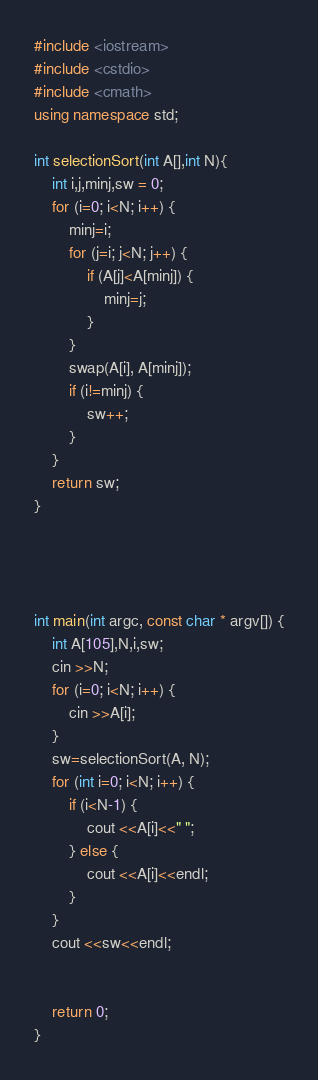<code> <loc_0><loc_0><loc_500><loc_500><_C++_>#include <iostream>
#include <cstdio>
#include <cmath>
using namespace std;

int selectionSort(int A[],int N){
    int i,j,minj,sw = 0;
    for (i=0; i<N; i++) {
        minj=i;
        for (j=i; j<N; j++) {
            if (A[j]<A[minj]) {
                minj=j;
            }
        }
        swap(A[i], A[minj]);
        if (i!=minj) {
            sw++;
        }
    }
    return sw;
}




int main(int argc, const char * argv[]) {
    int A[105],N,i,sw;
    cin >>N;
    for (i=0; i<N; i++) {
        cin >>A[i];
    }
    sw=selectionSort(A, N);
    for (int i=0; i<N; i++) {
        if (i<N-1) {
            cout <<A[i]<<" ";
        } else {
            cout <<A[i]<<endl;
        }
    }
    cout <<sw<<endl;
    
    
    return 0;
}

</code> 